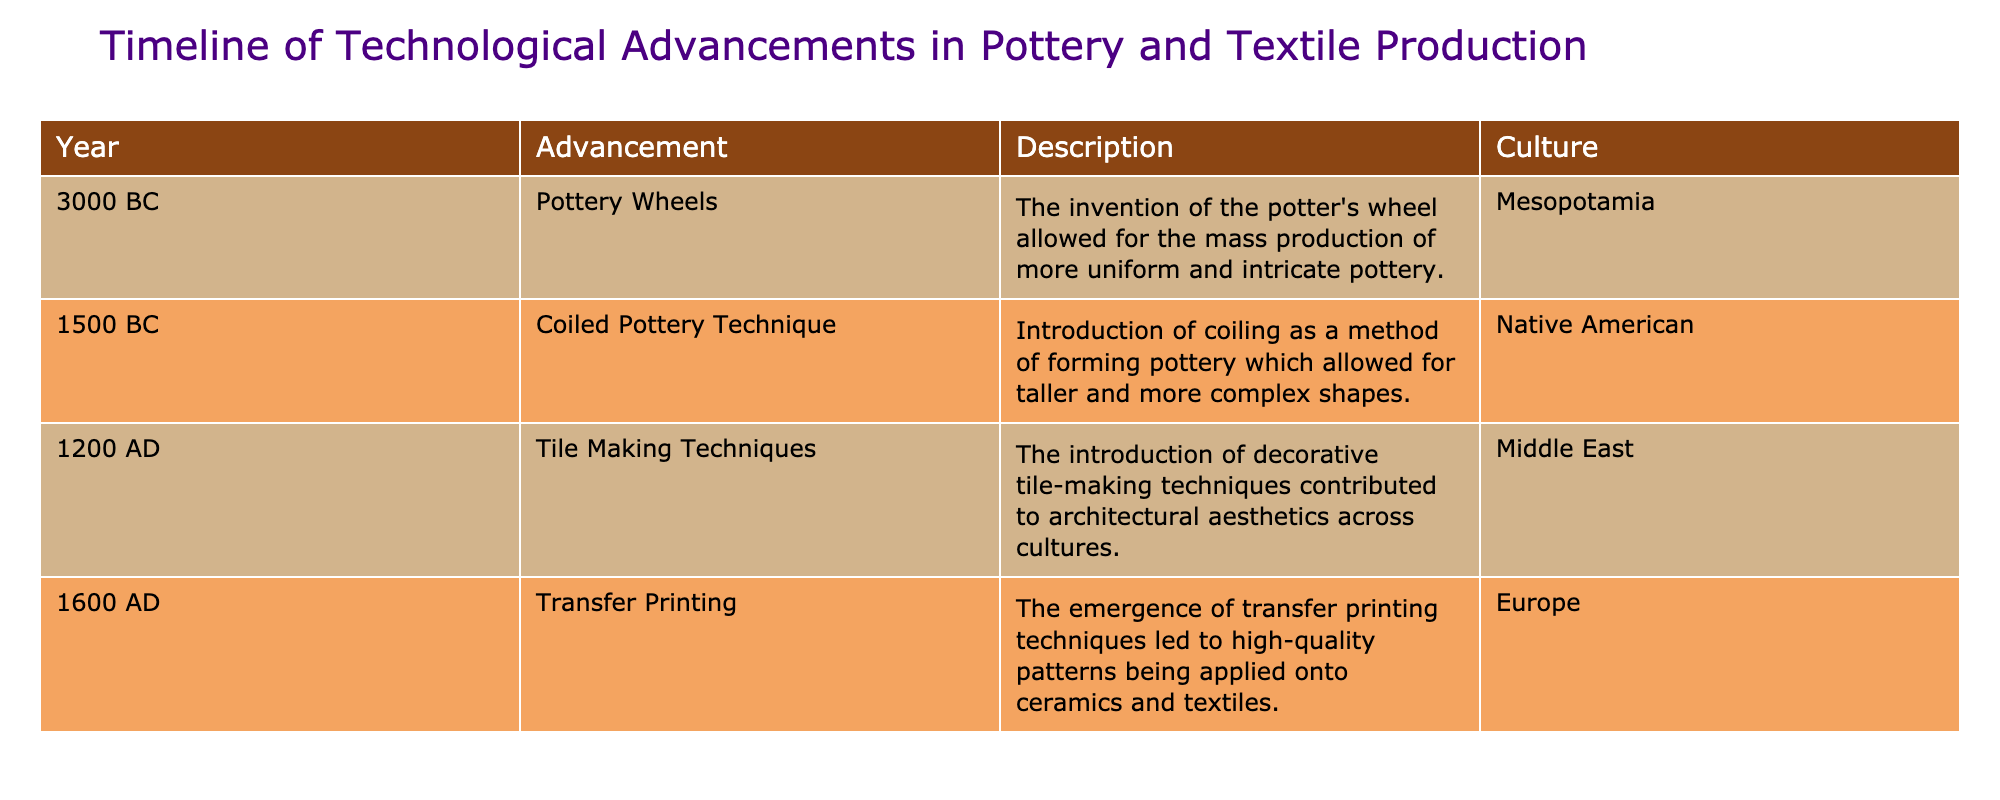What advancement was made in 3000 BC? The table indicates that in 3000 BC, the advancement made was the invention of the potter's wheel.
Answer: Potter's wheels Which culture introduced the coiled pottery technique? According to the table, the coiled pottery technique was introduced by Native American cultures.
Answer: Native American What is the earliest recorded technological advancement related to both pottery and textiles combined? The earliest recorded technological advancement listed in the table is the potter's wheel in 3000 BC, which applies to pottery. While the earliest textile-related advancement is not specifically mentioned, pottery advancements often align with textile production.
Answer: Potter's wheels (3000 BC) How many advancements are listed for the Middle East? The table lists one advancement for the Middle East, which is the introduction of tile-making techniques in 1200 AD.
Answer: One Was transfer printing developed before or after 1600 AD? Based on the table, transfer printing was specifically noted as an advancement that emerged in 1600 AD, indicating it was not developed prior to this year.
Answer: No, it was developed in 1600 AD Which advancement relates to architectural aesthetics? The table shows that tile-making techniques introduced in 1200 AD contributed to architectural aesthetics, linking this advancement directly to the enhancement of structures.
Answer: Tile making techniques If you sum the years of the two pottery advancements listed in the table, what is the result? The two pottery advancements are from 3000 BC (which can be interpreted as -3000) and 1500 BC (or -1500). Thus, summing these gives -3000 + (-1500) = -4500.
Answer: -4500 Which advancement followed the coiled pottery technique chronologically? Following the coiled pottery technique in 1500 BC, the next advancement listed is tile-making techniques in 1200 AD, marking a chronological progression from one method to another.
Answer: Tile making techniques In which era did Europe see an emergence of transfer printing techniques? The table specifies that Europe saw the emergence of transfer printing techniques in the year 1600 AD, marking a significant development in textile and ceramic production.
Answer: 1600 AD 